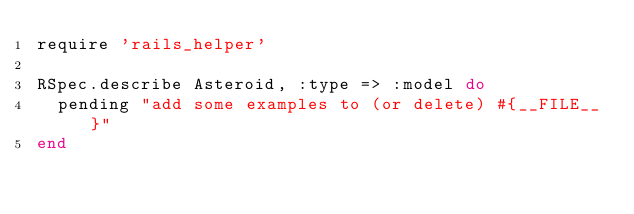Convert code to text. <code><loc_0><loc_0><loc_500><loc_500><_Ruby_>require 'rails_helper'

RSpec.describe Asteroid, :type => :model do
  pending "add some examples to (or delete) #{__FILE__}"
end
</code> 